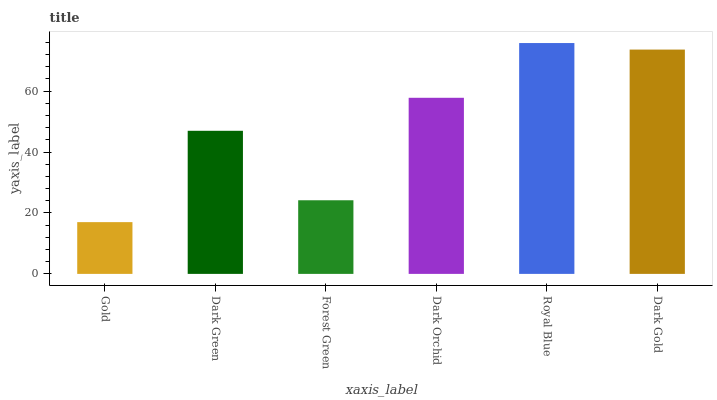Is Gold the minimum?
Answer yes or no. Yes. Is Royal Blue the maximum?
Answer yes or no. Yes. Is Dark Green the minimum?
Answer yes or no. No. Is Dark Green the maximum?
Answer yes or no. No. Is Dark Green greater than Gold?
Answer yes or no. Yes. Is Gold less than Dark Green?
Answer yes or no. Yes. Is Gold greater than Dark Green?
Answer yes or no. No. Is Dark Green less than Gold?
Answer yes or no. No. Is Dark Orchid the high median?
Answer yes or no. Yes. Is Dark Green the low median?
Answer yes or no. Yes. Is Gold the high median?
Answer yes or no. No. Is Royal Blue the low median?
Answer yes or no. No. 